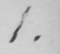What text is written in this handwritten line? 1 . 